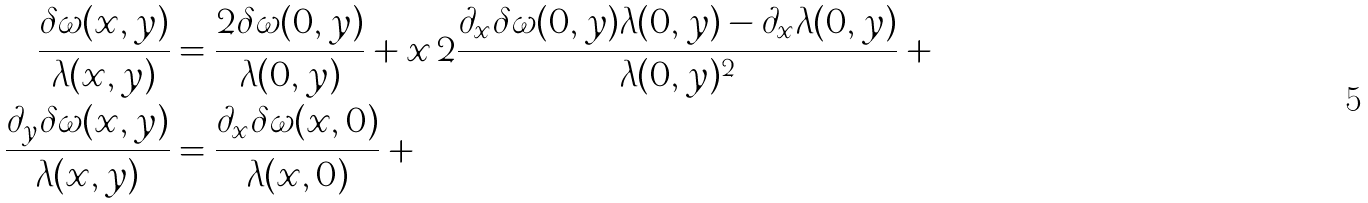<formula> <loc_0><loc_0><loc_500><loc_500>\frac { \delta \omega ( x , y ) } { \lambda ( x , y ) } & = \frac { 2 \delta \omega ( 0 , y ) } { \lambda ( 0 , y ) } + x \, 2 \frac { \partial _ { x } \delta \omega ( 0 , y ) \lambda ( 0 , y ) - \partial _ { x } \lambda ( 0 , y ) } { \lambda ( 0 , y ) ^ { 2 } } + \cdots \\ \frac { \partial _ { y } \delta \omega ( x , y ) } { \lambda ( x , y ) } & = \frac { \partial _ { x } \delta \omega ( x , 0 ) } { \lambda ( x , 0 ) } + \cdots</formula> 